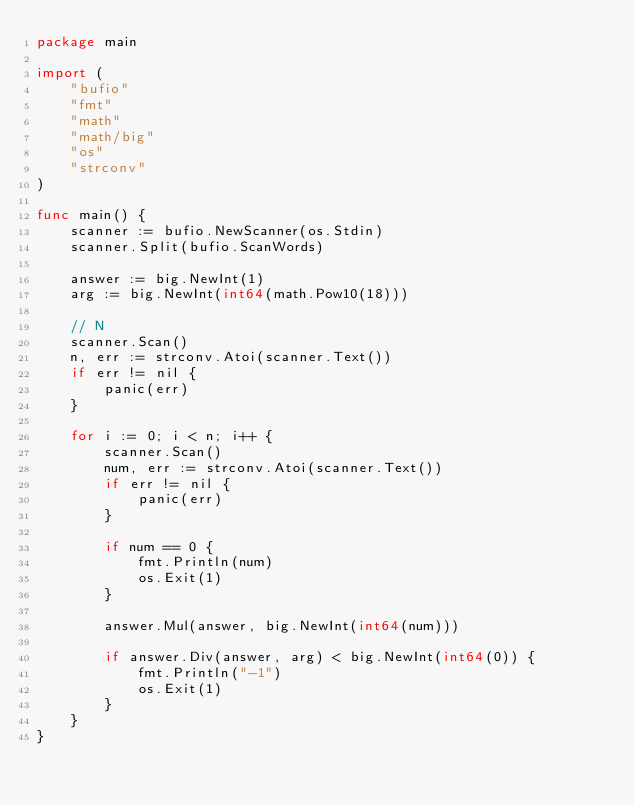<code> <loc_0><loc_0><loc_500><loc_500><_Go_>package main

import (
	"bufio"
	"fmt"
	"math"
	"math/big"
	"os"
	"strconv"
)

func main() {
	scanner := bufio.NewScanner(os.Stdin)
	scanner.Split(bufio.ScanWords)

	answer := big.NewInt(1)
	arg := big.NewInt(int64(math.Pow10(18)))

	// N
	scanner.Scan()
	n, err := strconv.Atoi(scanner.Text())
	if err != nil {
		panic(err)
	}

	for i := 0; i < n; i++ {
		scanner.Scan()
		num, err := strconv.Atoi(scanner.Text())
		if err != nil {
			panic(err)
		}

		if num == 0 {
			fmt.Println(num)
			os.Exit(1)
		}

		answer.Mul(answer, big.NewInt(int64(num)))

		if answer.Div(answer, arg) < big.NewInt(int64(0)) {
			fmt.Println("-1")
			os.Exit(1)
		}
	}
}
</code> 